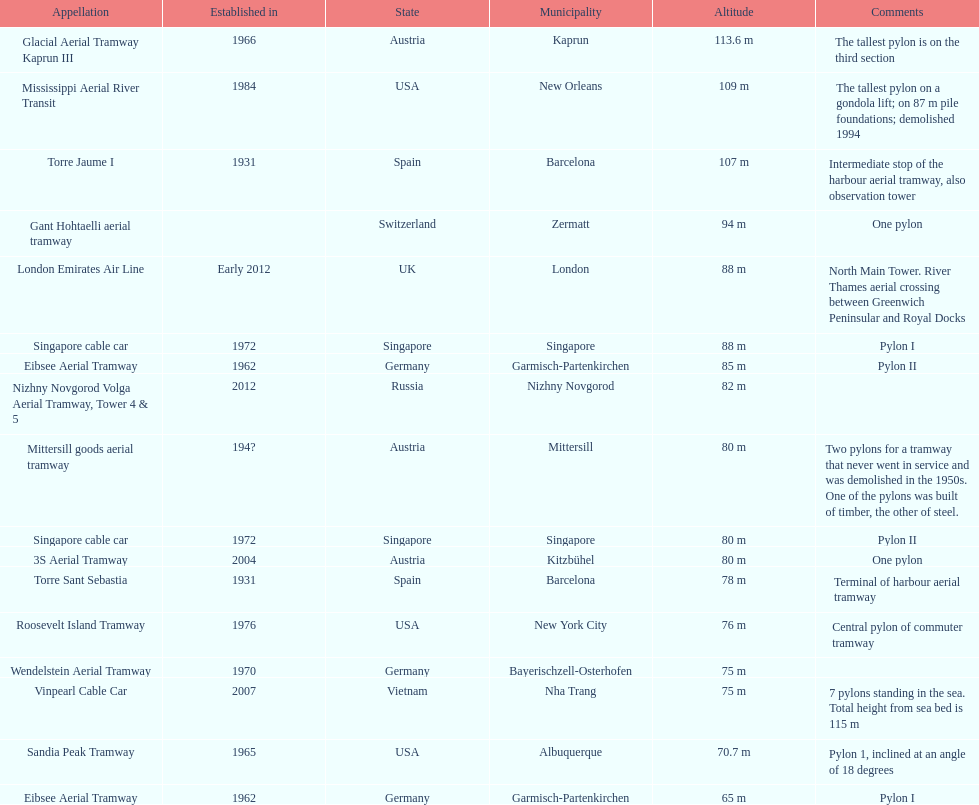What year was the last pylon in germany built? 1970. 